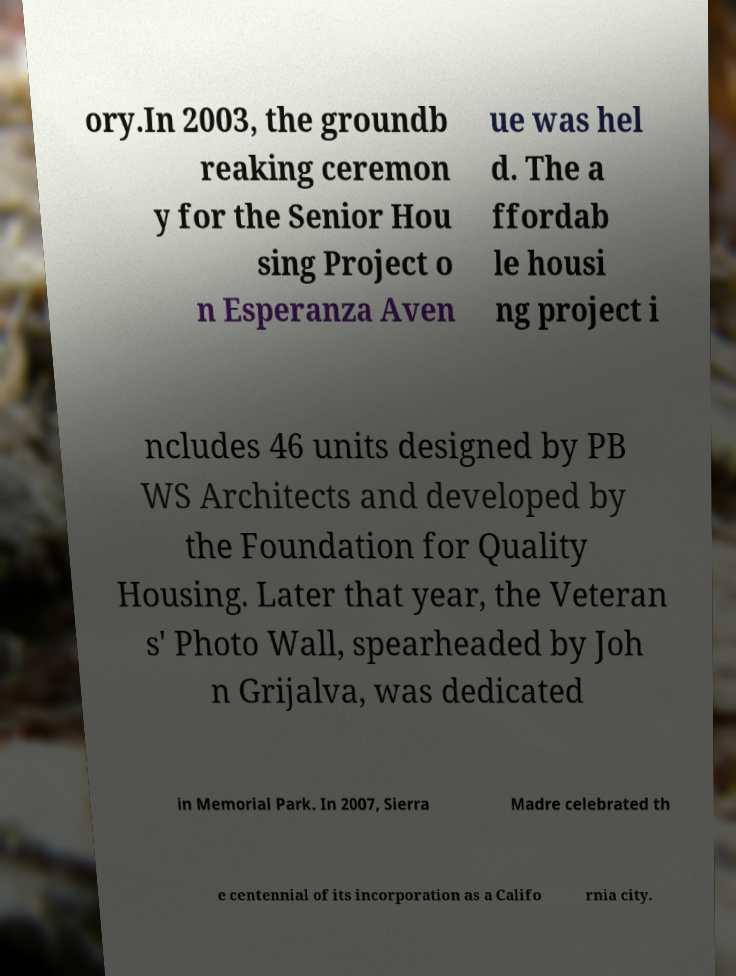There's text embedded in this image that I need extracted. Can you transcribe it verbatim? ory.In 2003, the groundb reaking ceremon y for the Senior Hou sing Project o n Esperanza Aven ue was hel d. The a ffordab le housi ng project i ncludes 46 units designed by PB WS Architects and developed by the Foundation for Quality Housing. Later that year, the Veteran s' Photo Wall, spearheaded by Joh n Grijalva, was dedicated in Memorial Park. In 2007, Sierra Madre celebrated th e centennial of its incorporation as a Califo rnia city. 